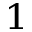<formula> <loc_0><loc_0><loc_500><loc_500>_ { 1 }</formula> 